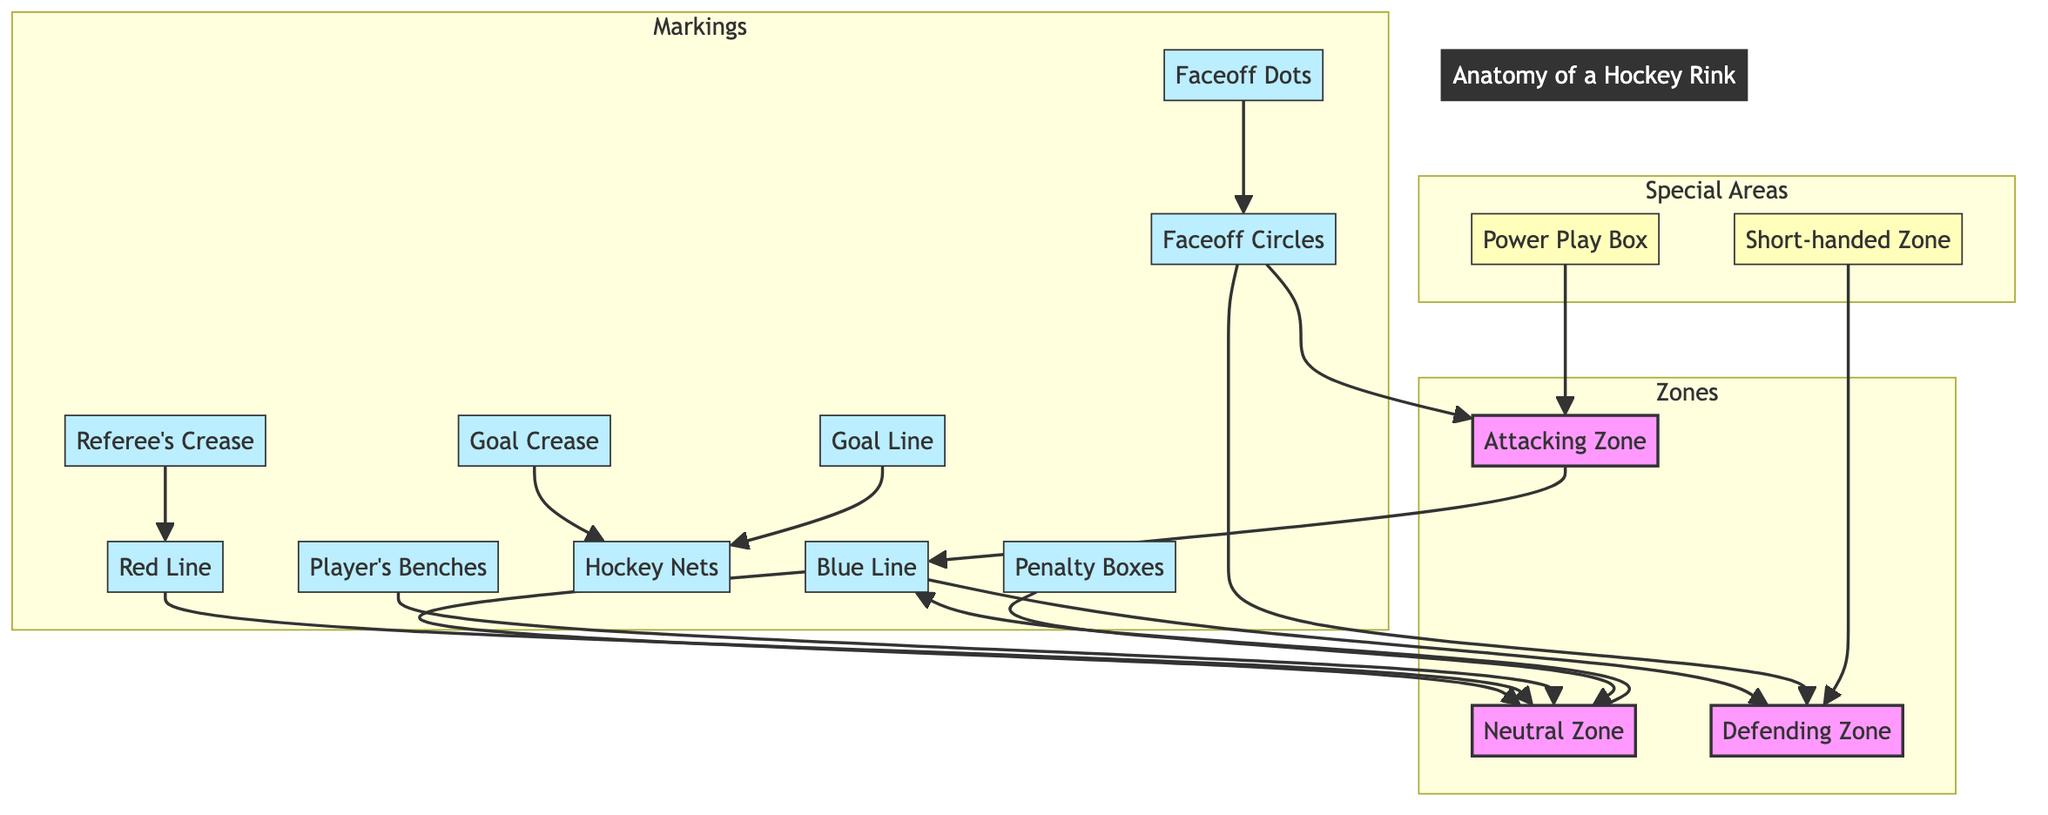What are the three main zones in a hockey rink? The main zones labeled in the diagram are the Attacking Zone, Neutral Zone, and Defending Zone. Each zone is connected, establishing the flow of play on the rink.
Answer: Attacking Zone, Neutral Zone, Defending Zone How many faceoff circles are in the diagram? The diagram shows two faceoff circles: one in the Attacking Zone and one in the Defending Zone.
Answer: 2 Which line separates the Attacking Zone and Neutral Zone? The blue line connects and separates the Attacking Zone from the Neutral Zone. It serves as a crucial marking for offsides and plays that cross from one zone to another.
Answer: Blue Line What marking is located in front of the goal? The diagram includes the Goal Crease marking, which is specifically identified as the area directly in front of the goalie, providing protection for the player in goal.
Answer: Goal Crease How many penalty boxes are present in the diagram? There are two penalty boxes labeled in the diagram, which are positioned to accommodate players serving penalties during the game.
Answer: 2 Which area is designated for players on power plays? The Power Play Box is specifically indicated in the diagram as the area where players take advantage of an opponent's penalty situation, allowing for a strategic offensive play.
Answer: Power Play Box What is the relationship between the Neutral Zone and the Red Line? The Neutral Zone is directly connected to the Red Line in the diagram, which indicates that the Red Line runs through the Neutral Zone, separating the two attacking areas of play.
Answer: Connected What is the role of the hockey nets in the diagram? The hockey nets are represented as the targets for scoring in the game, indicated in the diagram to show their importance in the layout of the rink.
Answer: Scoring targets 